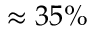<formula> <loc_0><loc_0><loc_500><loc_500>\approx 3 5 \%</formula> 